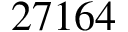Convert formula to latex. <formula><loc_0><loc_0><loc_500><loc_500>2 7 1 6 4</formula> 